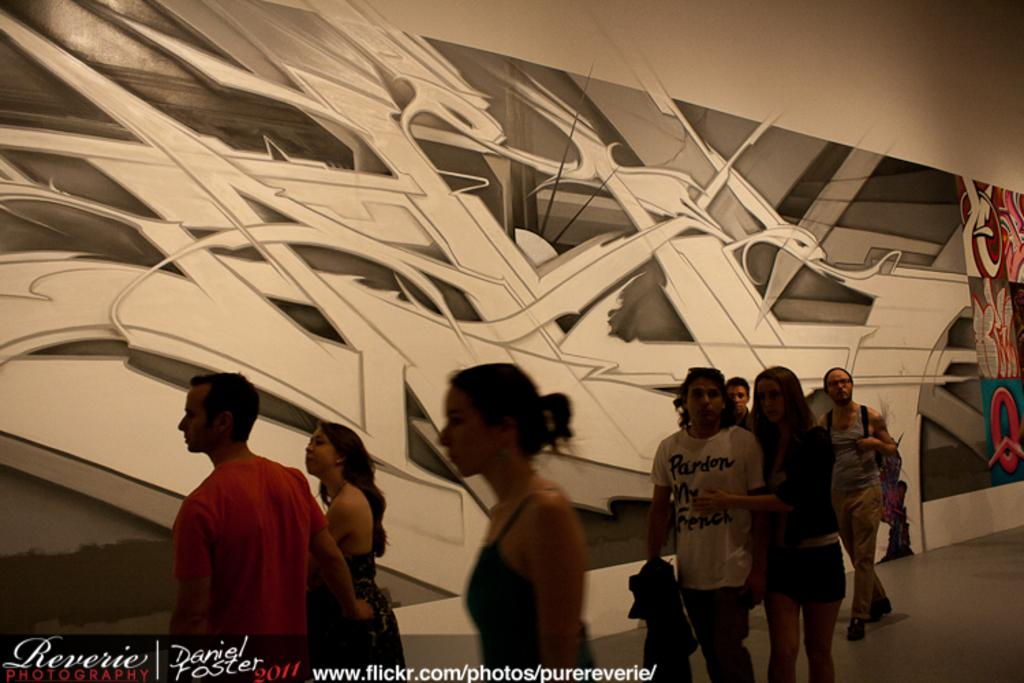How many people can be seen in the image? There are a few people in the image. What can be seen on the wall in the image? There is a wall with a design in the image. What is visible beneath the people in the image? The ground is visible in the image. What is written or displayed at the bottom of the image? There is some text at the bottom of the image. What type of sofa is placed in the shade in the image? There is no sofa or shade present in the image. 